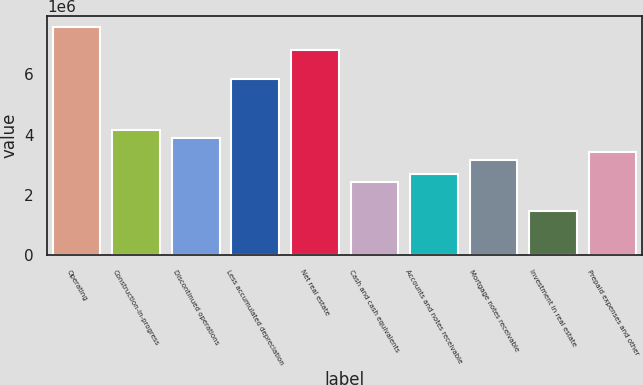Convert chart to OTSL. <chart><loc_0><loc_0><loc_500><loc_500><bar_chart><fcel>Operating<fcel>Construction-in-progress<fcel>Discontinued operations<fcel>Less accumulated depreciation<fcel>Net real estate<fcel>Cash and cash equivalents<fcel>Accounts and notes receivable<fcel>Mortgage notes receivable<fcel>Investment in real estate<fcel>Prepaid expenses and other<nl><fcel>7.547e+06<fcel>4.13892e+06<fcel>3.89548e+06<fcel>5.84296e+06<fcel>6.8167e+06<fcel>2.43488e+06<fcel>2.67831e+06<fcel>3.16518e+06<fcel>1.46114e+06<fcel>3.40862e+06<nl></chart> 